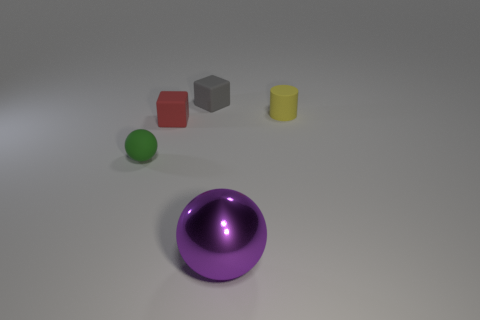Subtract 1 cubes. How many cubes are left? 1 Subtract all spheres. How many objects are left? 3 Add 2 purple balls. How many purple balls are left? 3 Add 3 large gray cylinders. How many large gray cylinders exist? 3 Add 5 small rubber balls. How many objects exist? 10 Subtract 1 red blocks. How many objects are left? 4 Subtract all red spheres. Subtract all yellow blocks. How many spheres are left? 2 Subtract all blue cubes. How many blue cylinders are left? 0 Subtract all brown rubber blocks. Subtract all tiny red matte cubes. How many objects are left? 4 